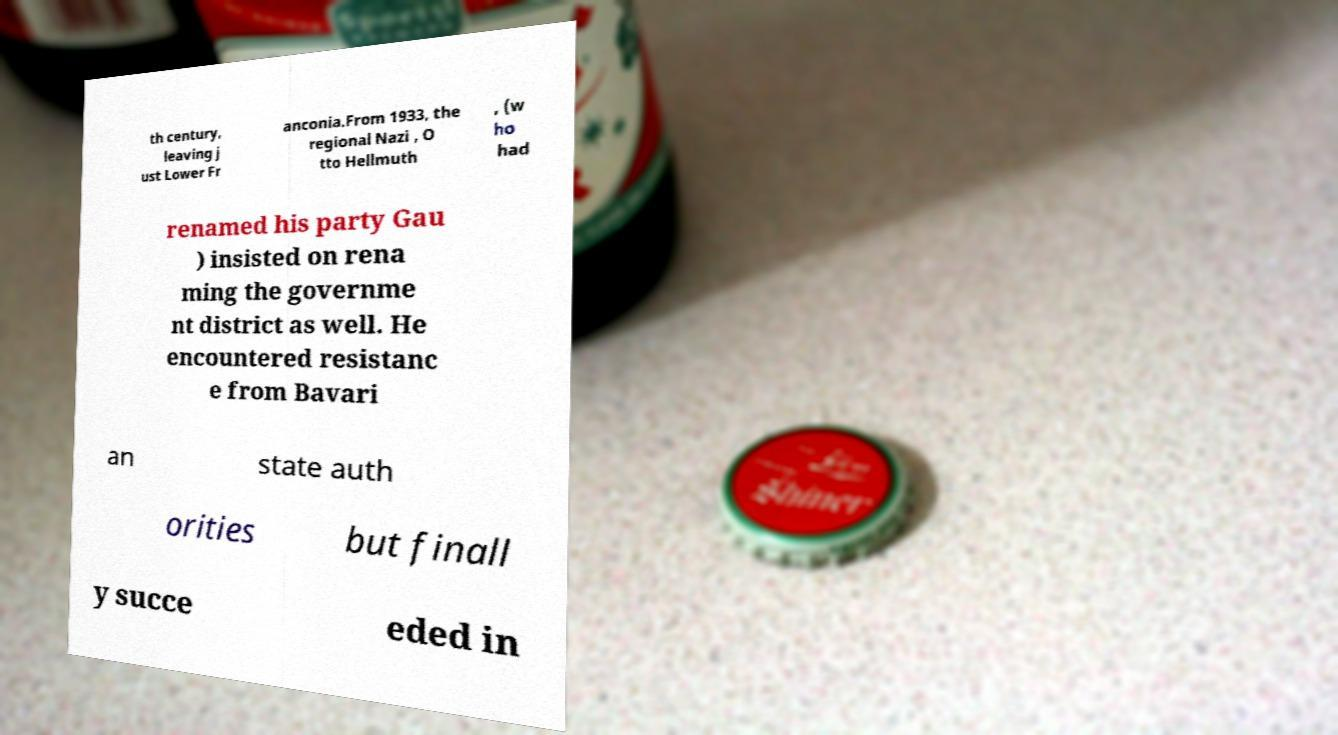Please read and relay the text visible in this image. What does it say? th century, leaving j ust Lower Fr anconia.From 1933, the regional Nazi , O tto Hellmuth , (w ho had renamed his party Gau ) insisted on rena ming the governme nt district as well. He encountered resistanc e from Bavari an state auth orities but finall y succe eded in 